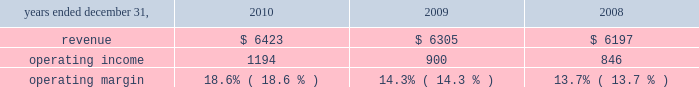Considered to be the primary beneficiary of either entity and have therefore deconsolidated both entities .
At december 31 , 2010 , we held a 36% ( 36 % ) interest in juniperus which is accounted for using the equity method of accounting .
Our potential loss at december 31 , 2010 is limited to our investment of $ 73 million in juniperus , which is recorded in investments in the consolidated statements of financial position .
We have not provided any financing to juniperus other than previously contractually required amounts .
Juniperus and jchl had combined assets and liabilities of $ 121 million and $ 22 million , respectively , at december 31 , 2008 .
For the year ended december 31 , 2009 , we recognized $ 36 million of pretax income from juniperus and jchl .
We recognized $ 16 million of after-tax income , after allocating the appropriate share of net income to the non-controlling interests .
We previously owned an 85% ( 85 % ) economic equity interest in globe re limited ( 2018 2018globe re 2019 2019 ) , a vie , which provided reinsurance coverage for a defined portfolio of property catastrophe reinsurance contracts underwritten by a third party for a limited period which ended june 1 , 2009 .
We consolidated globe re as we were deemed to be the primary beneficiary .
In connection with the winding up of its operations , globe re repaid its $ 100 million of short-term debt and our equity investment from available cash in 2009 .
We recognized $ 2 million of after-tax income from globe re in 2009 , taking into account the share of net income attributable to non-controlling interests .
Globe re was fully liquidated in the third quarter of 2009 .
Review by segment general we serve clients through the following segments : 2022 risk solutions ( formerly risk and insurance brokerage services ) acts as an advisor and insurance and reinsurance broker , helping clients manage their risks , via consultation , as well as negotiation and placement of insurance risk with insurance carriers through our global distribution network .
2022 hr solutions ( formerly consulting ) partners with organizations to solve their most complex benefits , talent and related financial challenges , and improve business performance by designing , implementing , communicating and administering a wide range of human capital , retirement , investment management , health care , compensation and talent management strategies .
Risk solutions .
The demand for property and casualty insurance generally rises as the overall level of economic activity increases and generally falls as such activity decreases , affecting both the commissions and fees generated by our brokerage business .
The economic activity that impacts property and casualty insurance is described as exposure units , and is most closely correlated with employment levels , corporate revenue and asset values .
During 2010 we continued to see a 2018 2018soft market 2019 2019 , which began in 2007 , in our retail brokerage product line .
In a soft market , premium rates flatten or decrease , along with commission revenues , due to increased competition for market share among insurance carriers or increased underwriting capacity .
Changes in premiums have a direct and potentially material impact on the insurance brokerage industry , as commission revenues are generally based on a percentage of the .
What was the average revenues from 2008 to 2010 in millions? 
Computations: (((6423 + 6305) + 6197) / 3)
Answer: 6308.33333. 